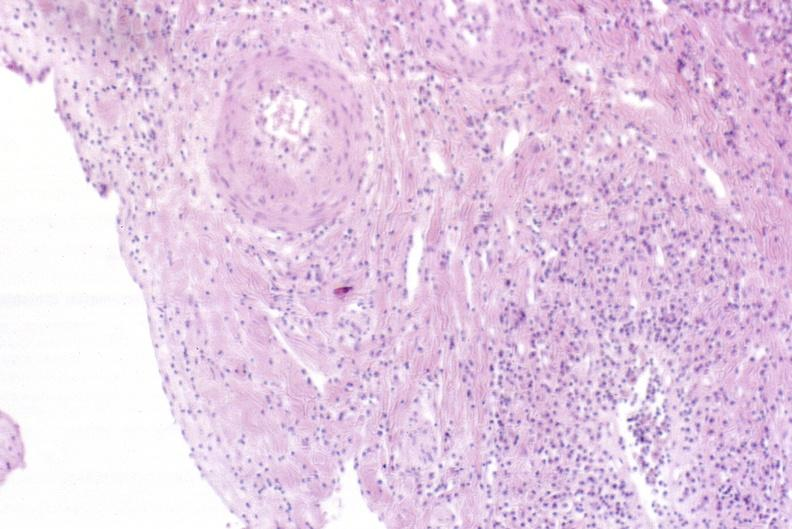what is present?
Answer the question using a single word or phrase. Liver 